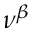Convert formula to latex. <formula><loc_0><loc_0><loc_500><loc_500>\nu ^ { \beta }</formula> 